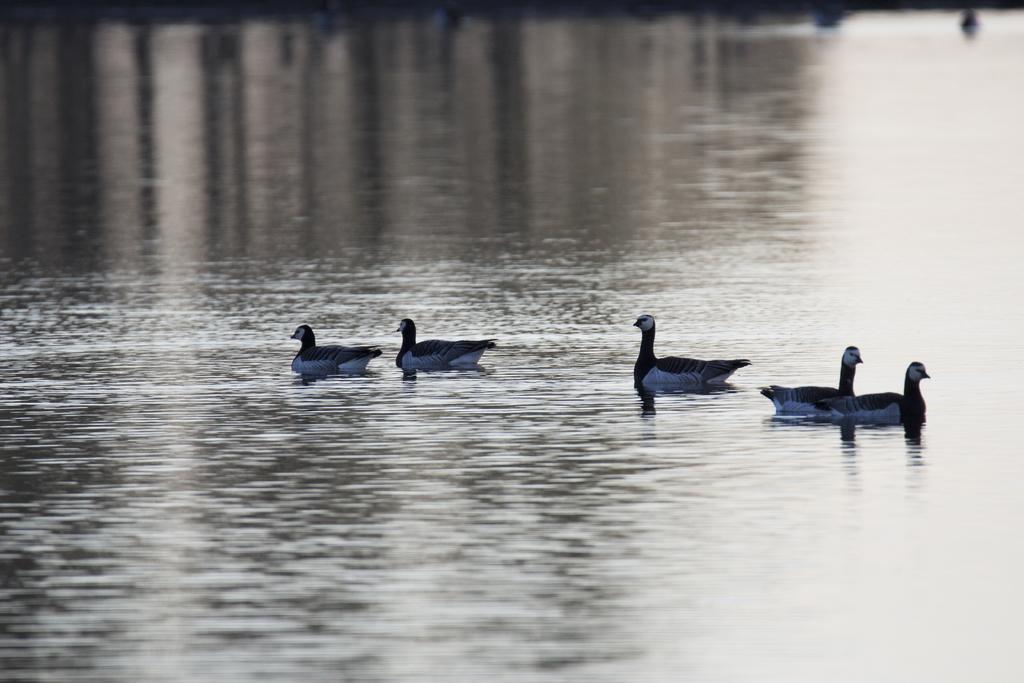How would you summarize this image in a sentence or two? In this image I can see few birds and water. They are in white and black color. 